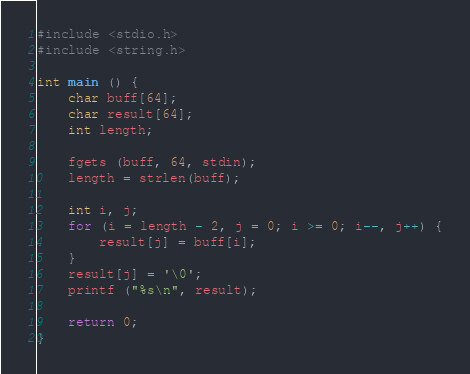Convert code to text. <code><loc_0><loc_0><loc_500><loc_500><_C_>#include <stdio.h>
#include <string.h>

int main () {
	char buff[64];
	char result[64];
	int length;
	
	fgets (buff, 64, stdin);
	length = strlen(buff);

	int i, j;
	for (i = length - 2, j = 0; i >= 0; i--, j++) {
		result[j] = buff[i];
	}
	result[j] = '\0';
	printf ("%s\n", result);
	
	return 0;
}

</code> 